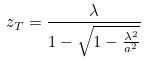<formula> <loc_0><loc_0><loc_500><loc_500>z _ { T } = \frac { \lambda } { 1 - \sqrt { 1 - \frac { \lambda ^ { 2 } } { a ^ { 2 } } } }</formula> 